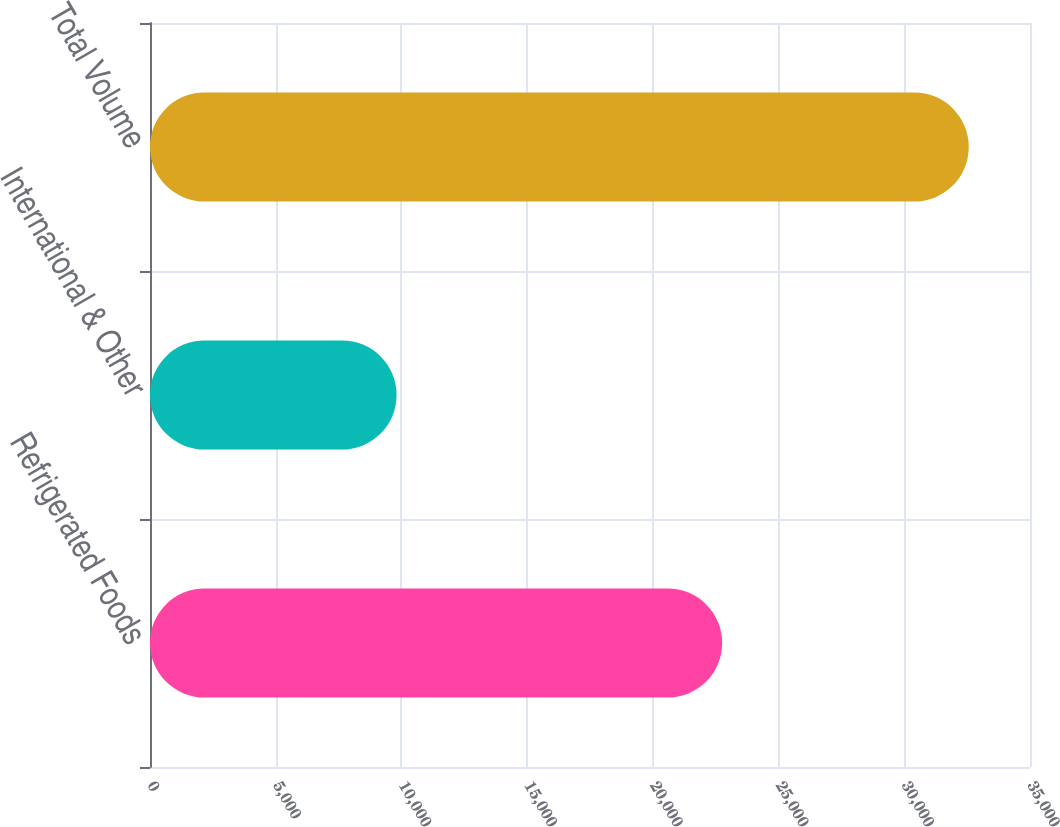Convert chart to OTSL. <chart><loc_0><loc_0><loc_500><loc_500><bar_chart><fcel>Refrigerated Foods<fcel>International & Other<fcel>Total Volume<nl><fcel>22757<fcel>9807<fcel>32564<nl></chart> 